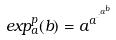<formula> <loc_0><loc_0><loc_500><loc_500>e x p _ { a } ^ { p } ( b ) = a ^ { a ^ { \cdot ^ { \cdot ^ { a ^ { b } } } } }</formula> 